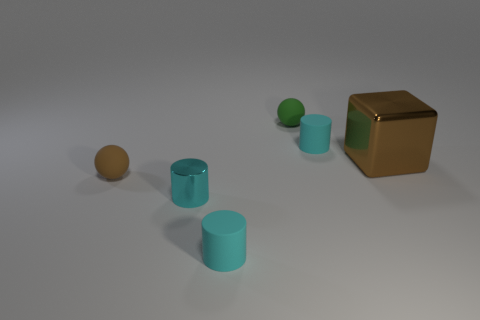Subtract all cyan cylinders. How many were subtracted if there are1cyan cylinders left? 2 Subtract all brown cylinders. Subtract all yellow spheres. How many cylinders are left? 3 Add 2 brown rubber spheres. How many objects exist? 8 Subtract all blocks. How many objects are left? 5 Add 2 tiny cylinders. How many tiny cylinders exist? 5 Subtract 0 red spheres. How many objects are left? 6 Subtract all tiny blue objects. Subtract all tiny spheres. How many objects are left? 4 Add 4 tiny cyan cylinders. How many tiny cyan cylinders are left? 7 